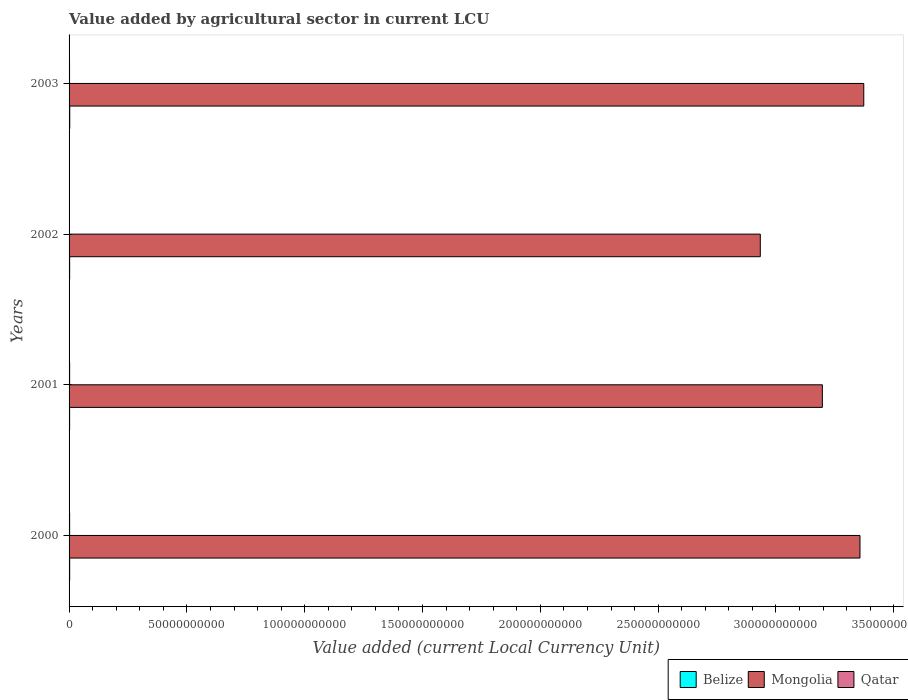How many different coloured bars are there?
Keep it short and to the point. 3. Are the number of bars per tick equal to the number of legend labels?
Offer a very short reply. Yes. In how many cases, is the number of bars for a given year not equal to the number of legend labels?
Your answer should be compact. 0. What is the value added by agricultural sector in Belize in 2002?
Provide a short and direct response. 2.46e+08. Across all years, what is the maximum value added by agricultural sector in Qatar?
Your answer should be very brief. 2.41e+08. Across all years, what is the minimum value added by agricultural sector in Qatar?
Your response must be concise. 1.81e+08. In which year was the value added by agricultural sector in Belize maximum?
Your response must be concise. 2003. In which year was the value added by agricultural sector in Belize minimum?
Provide a short and direct response. 2001. What is the total value added by agricultural sector in Mongolia in the graph?
Offer a very short reply. 1.29e+12. What is the difference between the value added by agricultural sector in Qatar in 2002 and that in 2003?
Offer a very short reply. -2.00e+07. What is the difference between the value added by agricultural sector in Belize in 2003 and the value added by agricultural sector in Mongolia in 2002?
Your answer should be compact. -2.93e+11. What is the average value added by agricultural sector in Belize per year?
Your answer should be very brief. 2.56e+08. In the year 2003, what is the difference between the value added by agricultural sector in Qatar and value added by agricultural sector in Mongolia?
Ensure brevity in your answer.  -3.37e+11. What is the ratio of the value added by agricultural sector in Qatar in 2001 to that in 2002?
Ensure brevity in your answer.  1.33. Is the value added by agricultural sector in Belize in 2001 less than that in 2002?
Keep it short and to the point. Yes. Is the difference between the value added by agricultural sector in Qatar in 2000 and 2001 greater than the difference between the value added by agricultural sector in Mongolia in 2000 and 2001?
Provide a short and direct response. No. What is the difference between the highest and the second highest value added by agricultural sector in Belize?
Provide a succinct answer. 3.43e+07. What is the difference between the highest and the lowest value added by agricultural sector in Belize?
Your answer should be very brief. 4.92e+07. What does the 2nd bar from the top in 2002 represents?
Your response must be concise. Mongolia. What does the 3rd bar from the bottom in 2003 represents?
Your answer should be very brief. Qatar. Is it the case that in every year, the sum of the value added by agricultural sector in Belize and value added by agricultural sector in Qatar is greater than the value added by agricultural sector in Mongolia?
Make the answer very short. No. How many years are there in the graph?
Give a very brief answer. 4. Are the values on the major ticks of X-axis written in scientific E-notation?
Give a very brief answer. No. What is the title of the graph?
Ensure brevity in your answer.  Value added by agricultural sector in current LCU. Does "Dominican Republic" appear as one of the legend labels in the graph?
Offer a terse response. No. What is the label or title of the X-axis?
Keep it short and to the point. Value added (current Local Currency Unit). What is the Value added (current Local Currency Unit) of Belize in 2000?
Provide a succinct answer. 2.53e+08. What is the Value added (current Local Currency Unit) of Mongolia in 2000?
Offer a terse response. 3.36e+11. What is the Value added (current Local Currency Unit) in Qatar in 2000?
Ensure brevity in your answer.  2.41e+08. What is the Value added (current Local Currency Unit) of Belize in 2001?
Ensure brevity in your answer.  2.38e+08. What is the Value added (current Local Currency Unit) in Mongolia in 2001?
Your response must be concise. 3.20e+11. What is the Value added (current Local Currency Unit) of Qatar in 2001?
Provide a short and direct response. 2.40e+08. What is the Value added (current Local Currency Unit) of Belize in 2002?
Your answer should be very brief. 2.46e+08. What is the Value added (current Local Currency Unit) in Mongolia in 2002?
Give a very brief answer. 2.93e+11. What is the Value added (current Local Currency Unit) in Qatar in 2002?
Make the answer very short. 1.81e+08. What is the Value added (current Local Currency Unit) in Belize in 2003?
Ensure brevity in your answer.  2.87e+08. What is the Value added (current Local Currency Unit) in Mongolia in 2003?
Offer a very short reply. 3.37e+11. What is the Value added (current Local Currency Unit) in Qatar in 2003?
Offer a terse response. 2.01e+08. Across all years, what is the maximum Value added (current Local Currency Unit) of Belize?
Give a very brief answer. 2.87e+08. Across all years, what is the maximum Value added (current Local Currency Unit) of Mongolia?
Your answer should be compact. 3.37e+11. Across all years, what is the maximum Value added (current Local Currency Unit) of Qatar?
Your response must be concise. 2.41e+08. Across all years, what is the minimum Value added (current Local Currency Unit) in Belize?
Your answer should be very brief. 2.38e+08. Across all years, what is the minimum Value added (current Local Currency Unit) in Mongolia?
Your answer should be very brief. 2.93e+11. Across all years, what is the minimum Value added (current Local Currency Unit) of Qatar?
Your answer should be compact. 1.81e+08. What is the total Value added (current Local Currency Unit) in Belize in the graph?
Make the answer very short. 1.02e+09. What is the total Value added (current Local Currency Unit) of Mongolia in the graph?
Your answer should be very brief. 1.29e+12. What is the total Value added (current Local Currency Unit) in Qatar in the graph?
Your response must be concise. 8.63e+08. What is the difference between the Value added (current Local Currency Unit) in Belize in 2000 and that in 2001?
Make the answer very short. 1.49e+07. What is the difference between the Value added (current Local Currency Unit) in Mongolia in 2000 and that in 2001?
Provide a succinct answer. 1.60e+1. What is the difference between the Value added (current Local Currency Unit) of Qatar in 2000 and that in 2001?
Give a very brief answer. 1.00e+06. What is the difference between the Value added (current Local Currency Unit) in Belize in 2000 and that in 2002?
Provide a succinct answer. 7.16e+06. What is the difference between the Value added (current Local Currency Unit) of Mongolia in 2000 and that in 2002?
Give a very brief answer. 4.23e+1. What is the difference between the Value added (current Local Currency Unit) of Qatar in 2000 and that in 2002?
Make the answer very short. 6.00e+07. What is the difference between the Value added (current Local Currency Unit) in Belize in 2000 and that in 2003?
Offer a terse response. -3.43e+07. What is the difference between the Value added (current Local Currency Unit) in Mongolia in 2000 and that in 2003?
Keep it short and to the point. -1.60e+09. What is the difference between the Value added (current Local Currency Unit) of Qatar in 2000 and that in 2003?
Offer a terse response. 4.00e+07. What is the difference between the Value added (current Local Currency Unit) in Belize in 2001 and that in 2002?
Provide a succinct answer. -7.74e+06. What is the difference between the Value added (current Local Currency Unit) of Mongolia in 2001 and that in 2002?
Offer a terse response. 2.63e+1. What is the difference between the Value added (current Local Currency Unit) in Qatar in 2001 and that in 2002?
Offer a terse response. 5.90e+07. What is the difference between the Value added (current Local Currency Unit) in Belize in 2001 and that in 2003?
Offer a very short reply. -4.92e+07. What is the difference between the Value added (current Local Currency Unit) of Mongolia in 2001 and that in 2003?
Your answer should be very brief. -1.76e+1. What is the difference between the Value added (current Local Currency Unit) in Qatar in 2001 and that in 2003?
Provide a short and direct response. 3.90e+07. What is the difference between the Value added (current Local Currency Unit) of Belize in 2002 and that in 2003?
Ensure brevity in your answer.  -4.15e+07. What is the difference between the Value added (current Local Currency Unit) of Mongolia in 2002 and that in 2003?
Provide a succinct answer. -4.39e+1. What is the difference between the Value added (current Local Currency Unit) in Qatar in 2002 and that in 2003?
Your answer should be compact. -2.00e+07. What is the difference between the Value added (current Local Currency Unit) in Belize in 2000 and the Value added (current Local Currency Unit) in Mongolia in 2001?
Your response must be concise. -3.19e+11. What is the difference between the Value added (current Local Currency Unit) of Belize in 2000 and the Value added (current Local Currency Unit) of Qatar in 2001?
Keep it short and to the point. 1.28e+07. What is the difference between the Value added (current Local Currency Unit) in Mongolia in 2000 and the Value added (current Local Currency Unit) in Qatar in 2001?
Your answer should be compact. 3.35e+11. What is the difference between the Value added (current Local Currency Unit) of Belize in 2000 and the Value added (current Local Currency Unit) of Mongolia in 2002?
Your answer should be compact. -2.93e+11. What is the difference between the Value added (current Local Currency Unit) of Belize in 2000 and the Value added (current Local Currency Unit) of Qatar in 2002?
Give a very brief answer. 7.18e+07. What is the difference between the Value added (current Local Currency Unit) in Mongolia in 2000 and the Value added (current Local Currency Unit) in Qatar in 2002?
Make the answer very short. 3.35e+11. What is the difference between the Value added (current Local Currency Unit) of Belize in 2000 and the Value added (current Local Currency Unit) of Mongolia in 2003?
Offer a very short reply. -3.37e+11. What is the difference between the Value added (current Local Currency Unit) of Belize in 2000 and the Value added (current Local Currency Unit) of Qatar in 2003?
Your answer should be very brief. 5.18e+07. What is the difference between the Value added (current Local Currency Unit) in Mongolia in 2000 and the Value added (current Local Currency Unit) in Qatar in 2003?
Give a very brief answer. 3.35e+11. What is the difference between the Value added (current Local Currency Unit) in Belize in 2001 and the Value added (current Local Currency Unit) in Mongolia in 2002?
Offer a terse response. -2.93e+11. What is the difference between the Value added (current Local Currency Unit) in Belize in 2001 and the Value added (current Local Currency Unit) in Qatar in 2002?
Provide a succinct answer. 5.69e+07. What is the difference between the Value added (current Local Currency Unit) of Mongolia in 2001 and the Value added (current Local Currency Unit) of Qatar in 2002?
Give a very brief answer. 3.20e+11. What is the difference between the Value added (current Local Currency Unit) in Belize in 2001 and the Value added (current Local Currency Unit) in Mongolia in 2003?
Give a very brief answer. -3.37e+11. What is the difference between the Value added (current Local Currency Unit) in Belize in 2001 and the Value added (current Local Currency Unit) in Qatar in 2003?
Provide a short and direct response. 3.69e+07. What is the difference between the Value added (current Local Currency Unit) of Mongolia in 2001 and the Value added (current Local Currency Unit) of Qatar in 2003?
Your answer should be compact. 3.19e+11. What is the difference between the Value added (current Local Currency Unit) of Belize in 2002 and the Value added (current Local Currency Unit) of Mongolia in 2003?
Offer a very short reply. -3.37e+11. What is the difference between the Value added (current Local Currency Unit) of Belize in 2002 and the Value added (current Local Currency Unit) of Qatar in 2003?
Offer a terse response. 4.46e+07. What is the difference between the Value added (current Local Currency Unit) of Mongolia in 2002 and the Value added (current Local Currency Unit) of Qatar in 2003?
Your response must be concise. 2.93e+11. What is the average Value added (current Local Currency Unit) of Belize per year?
Your response must be concise. 2.56e+08. What is the average Value added (current Local Currency Unit) of Mongolia per year?
Make the answer very short. 3.22e+11. What is the average Value added (current Local Currency Unit) of Qatar per year?
Offer a terse response. 2.16e+08. In the year 2000, what is the difference between the Value added (current Local Currency Unit) in Belize and Value added (current Local Currency Unit) in Mongolia?
Keep it short and to the point. -3.35e+11. In the year 2000, what is the difference between the Value added (current Local Currency Unit) in Belize and Value added (current Local Currency Unit) in Qatar?
Your answer should be compact. 1.18e+07. In the year 2000, what is the difference between the Value added (current Local Currency Unit) in Mongolia and Value added (current Local Currency Unit) in Qatar?
Offer a very short reply. 3.35e+11. In the year 2001, what is the difference between the Value added (current Local Currency Unit) in Belize and Value added (current Local Currency Unit) in Mongolia?
Your answer should be very brief. -3.19e+11. In the year 2001, what is the difference between the Value added (current Local Currency Unit) of Belize and Value added (current Local Currency Unit) of Qatar?
Your response must be concise. -2.10e+06. In the year 2001, what is the difference between the Value added (current Local Currency Unit) of Mongolia and Value added (current Local Currency Unit) of Qatar?
Offer a very short reply. 3.19e+11. In the year 2002, what is the difference between the Value added (current Local Currency Unit) in Belize and Value added (current Local Currency Unit) in Mongolia?
Keep it short and to the point. -2.93e+11. In the year 2002, what is the difference between the Value added (current Local Currency Unit) of Belize and Value added (current Local Currency Unit) of Qatar?
Your answer should be compact. 6.46e+07. In the year 2002, what is the difference between the Value added (current Local Currency Unit) of Mongolia and Value added (current Local Currency Unit) of Qatar?
Keep it short and to the point. 2.93e+11. In the year 2003, what is the difference between the Value added (current Local Currency Unit) in Belize and Value added (current Local Currency Unit) in Mongolia?
Give a very brief answer. -3.37e+11. In the year 2003, what is the difference between the Value added (current Local Currency Unit) in Belize and Value added (current Local Currency Unit) in Qatar?
Make the answer very short. 8.61e+07. In the year 2003, what is the difference between the Value added (current Local Currency Unit) of Mongolia and Value added (current Local Currency Unit) of Qatar?
Your response must be concise. 3.37e+11. What is the ratio of the Value added (current Local Currency Unit) of Belize in 2000 to that in 2001?
Provide a short and direct response. 1.06. What is the ratio of the Value added (current Local Currency Unit) of Belize in 2000 to that in 2002?
Offer a terse response. 1.03. What is the ratio of the Value added (current Local Currency Unit) in Mongolia in 2000 to that in 2002?
Provide a succinct answer. 1.14. What is the ratio of the Value added (current Local Currency Unit) of Qatar in 2000 to that in 2002?
Provide a short and direct response. 1.33. What is the ratio of the Value added (current Local Currency Unit) in Belize in 2000 to that in 2003?
Provide a succinct answer. 0.88. What is the ratio of the Value added (current Local Currency Unit) of Qatar in 2000 to that in 2003?
Your answer should be very brief. 1.2. What is the ratio of the Value added (current Local Currency Unit) of Belize in 2001 to that in 2002?
Keep it short and to the point. 0.97. What is the ratio of the Value added (current Local Currency Unit) in Mongolia in 2001 to that in 2002?
Offer a very short reply. 1.09. What is the ratio of the Value added (current Local Currency Unit) of Qatar in 2001 to that in 2002?
Your answer should be compact. 1.33. What is the ratio of the Value added (current Local Currency Unit) of Belize in 2001 to that in 2003?
Give a very brief answer. 0.83. What is the ratio of the Value added (current Local Currency Unit) of Mongolia in 2001 to that in 2003?
Provide a succinct answer. 0.95. What is the ratio of the Value added (current Local Currency Unit) of Qatar in 2001 to that in 2003?
Your answer should be very brief. 1.19. What is the ratio of the Value added (current Local Currency Unit) in Belize in 2002 to that in 2003?
Ensure brevity in your answer.  0.86. What is the ratio of the Value added (current Local Currency Unit) of Mongolia in 2002 to that in 2003?
Your response must be concise. 0.87. What is the ratio of the Value added (current Local Currency Unit) of Qatar in 2002 to that in 2003?
Ensure brevity in your answer.  0.9. What is the difference between the highest and the second highest Value added (current Local Currency Unit) in Belize?
Your answer should be very brief. 3.43e+07. What is the difference between the highest and the second highest Value added (current Local Currency Unit) of Mongolia?
Your answer should be compact. 1.60e+09. What is the difference between the highest and the lowest Value added (current Local Currency Unit) of Belize?
Your answer should be compact. 4.92e+07. What is the difference between the highest and the lowest Value added (current Local Currency Unit) in Mongolia?
Your answer should be very brief. 4.39e+1. What is the difference between the highest and the lowest Value added (current Local Currency Unit) in Qatar?
Your response must be concise. 6.00e+07. 